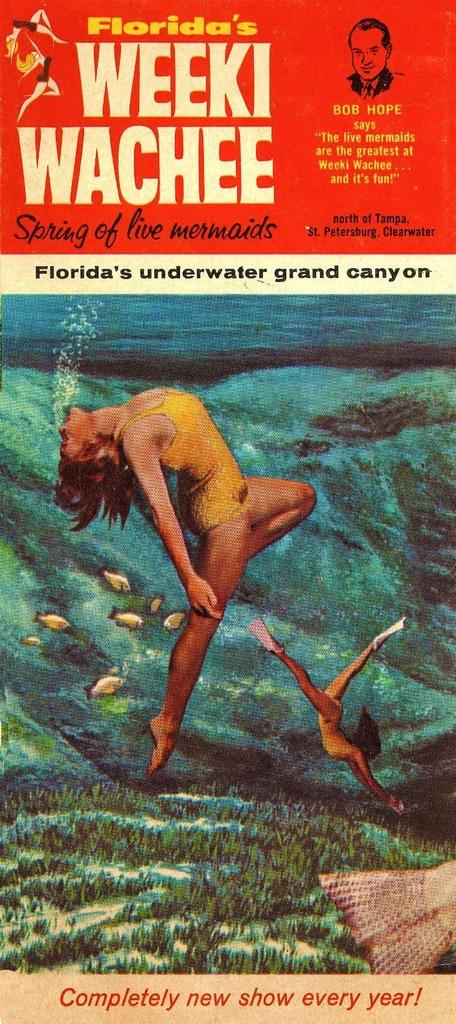What is present on the poster in the image? The poster contains pictures and text. Can you describe the content of the poster? The poster contains pictures and text, but the specific content cannot be determined from the provided facts. Where is the shelf located in the image? There is no shelf present in the image. Can you see any cheese on the poster in the image? There is no cheese present on the poster in the image. Are there any snails visible on the poster in the image? There is no mention of snails in the provided facts, and therefore no snails can be seen on the poster in the image. 